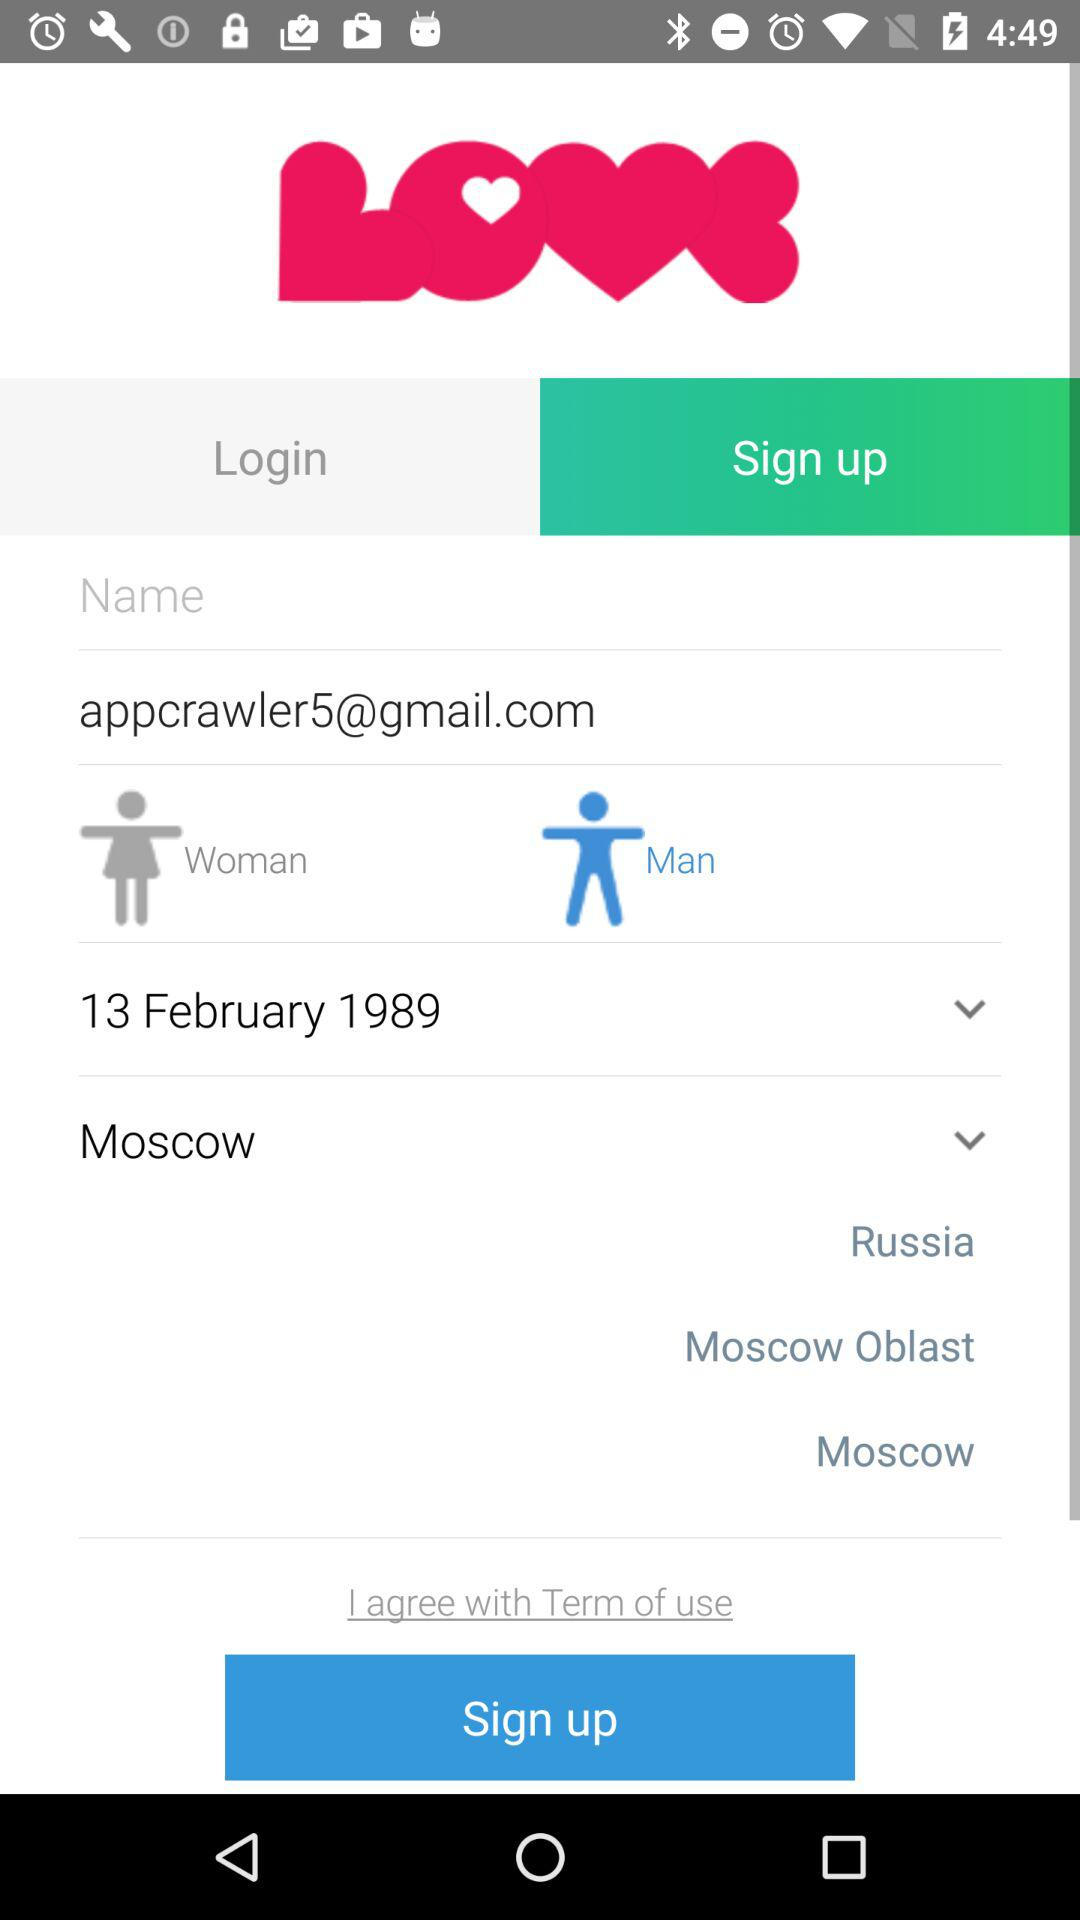How many options are there for gender?
Answer the question using a single word or phrase. 2 